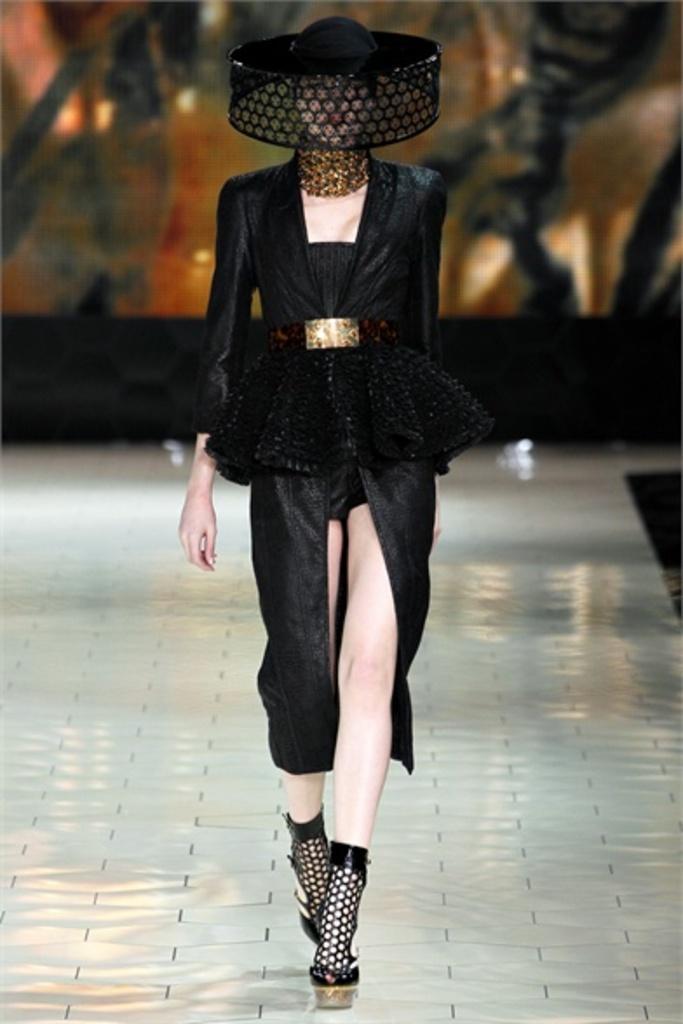Could you give a brief overview of what you see in this image? In the picture i can see a woman wearing black color dress, hat and footwear walking through the surface which is of silver color. 